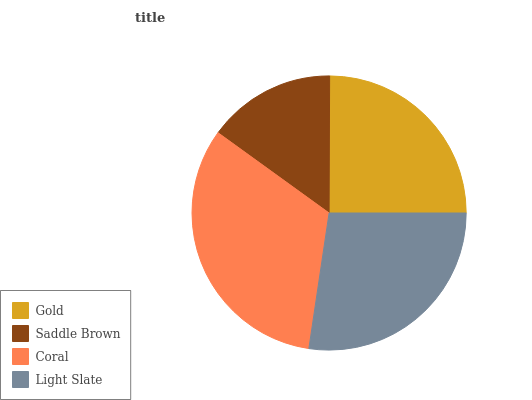Is Saddle Brown the minimum?
Answer yes or no. Yes. Is Coral the maximum?
Answer yes or no. Yes. Is Coral the minimum?
Answer yes or no. No. Is Saddle Brown the maximum?
Answer yes or no. No. Is Coral greater than Saddle Brown?
Answer yes or no. Yes. Is Saddle Brown less than Coral?
Answer yes or no. Yes. Is Saddle Brown greater than Coral?
Answer yes or no. No. Is Coral less than Saddle Brown?
Answer yes or no. No. Is Light Slate the high median?
Answer yes or no. Yes. Is Gold the low median?
Answer yes or no. Yes. Is Coral the high median?
Answer yes or no. No. Is Coral the low median?
Answer yes or no. No. 